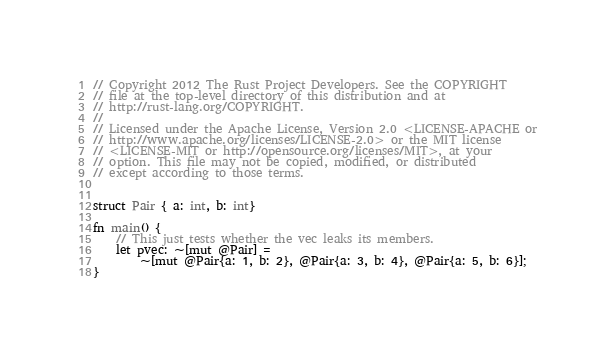Convert code to text. <code><loc_0><loc_0><loc_500><loc_500><_Rust_>// Copyright 2012 The Rust Project Developers. See the COPYRIGHT
// file at the top-level directory of this distribution and at
// http://rust-lang.org/COPYRIGHT.
//
// Licensed under the Apache License, Version 2.0 <LICENSE-APACHE or
// http://www.apache.org/licenses/LICENSE-2.0> or the MIT license
// <LICENSE-MIT or http://opensource.org/licenses/MIT>, at your
// option. This file may not be copied, modified, or distributed
// except according to those terms.


struct Pair { a: int, b: int}

fn main() {
    // This just tests whether the vec leaks its members.
    let pvec: ~[mut @Pair] =
        ~[mut @Pair{a: 1, b: 2}, @Pair{a: 3, b: 4}, @Pair{a: 5, b: 6}];
}
</code> 